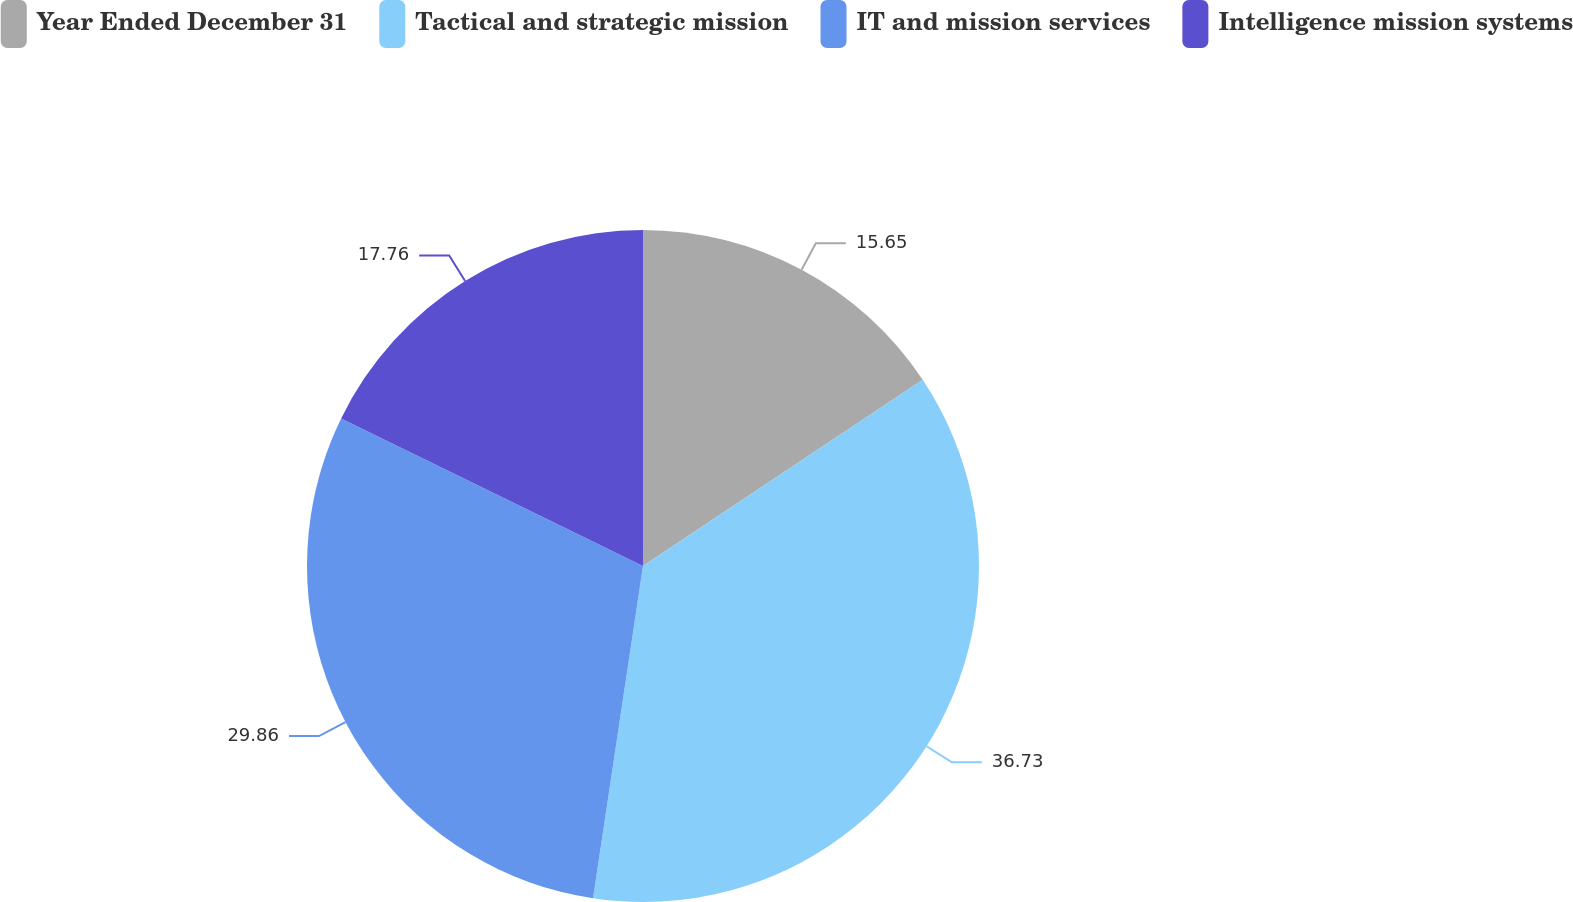Convert chart. <chart><loc_0><loc_0><loc_500><loc_500><pie_chart><fcel>Year Ended December 31<fcel>Tactical and strategic mission<fcel>IT and mission services<fcel>Intelligence mission systems<nl><fcel>15.65%<fcel>36.72%<fcel>29.86%<fcel>17.76%<nl></chart> 